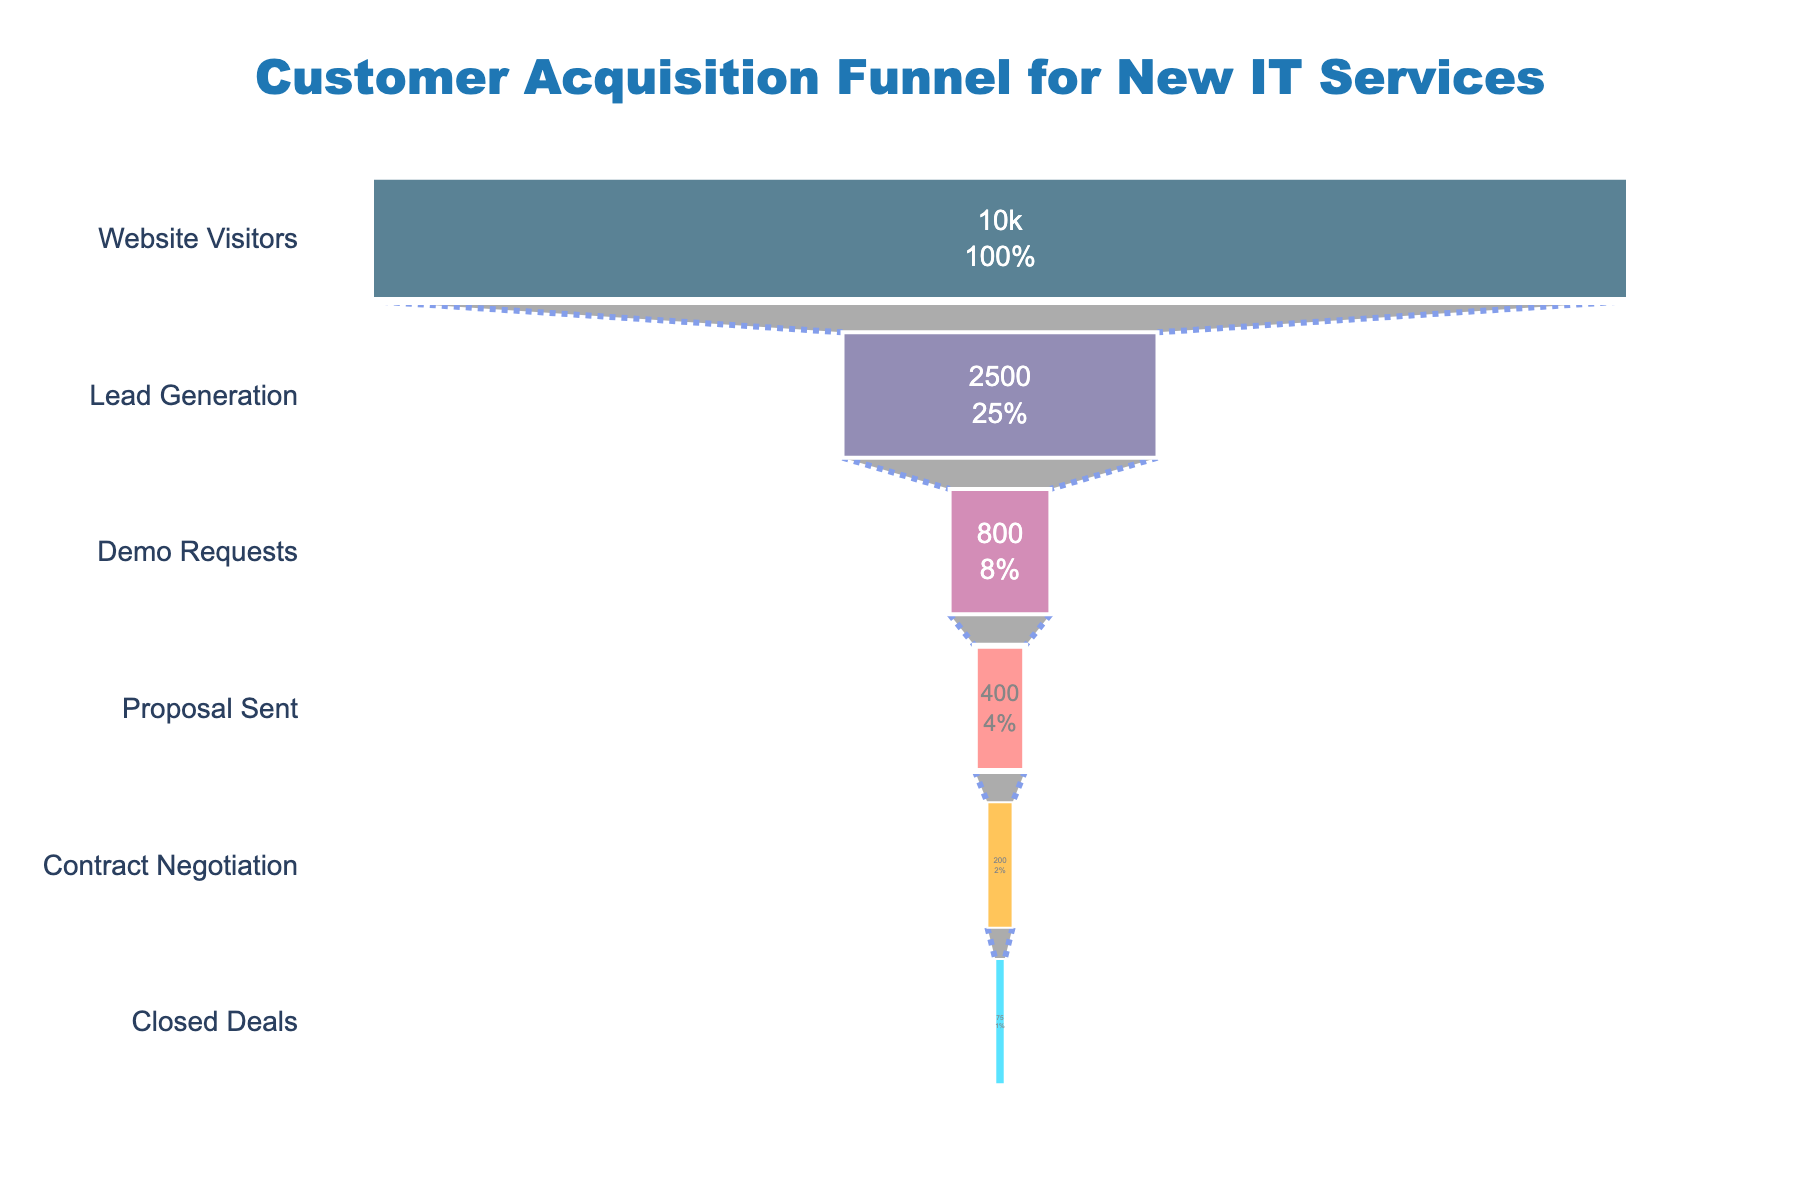How many total stages are shown in the funnel chart? The funnel chart displays multiple stages, starting from 'Website Visitors' and proceeding to 'Closed Deals'. By counting these stages, we find there are six distinct stages.
Answer: 6 Which stage has the highest number of prospects? By looking at the funnel chart, we see that 'Website Visitors' is the stage with the most prospects, at 10,000.
Answer: Website Visitors What percentage of prospects reach the 'Demo Requests' stage? To find the percentage, divide the number of 'Demo Requests' (800) by the number of 'Website Visitors' (10,000) and multiply by 100. Calculation: (800 / 10,000) * 100 = 8%.
Answer: 8% How many prospects do not make it from 'Lead Generation' to 'Demo Requests'? Subtract the number of prospects at the 'Demo Requests' stage (800) from those at the 'Lead Generation' stage (2500). Calculation: 2500 - 800 = 1700.
Answer: 1700 Which stage has the highest drop-off rate from the previous stage? To find the highest drop-off rate, calculate the drop-off percentage between each consecutive stage: 
- From 'Website Visitors' to 'Lead Generation': (10000 - 2500) / 10000 * 100 = 75%
- From 'Lead Generation' to 'Demo Requests': (2500 - 800) / 2500 * 100 = 68%
- From 'Demo Requests' to 'Proposal Sent': (800 - 400) / 800 * 100 = 50%
- From 'Proposal Sent' to 'Contract Negotiation': (400 - 200) / 400 * 100 = 50%
- From 'Contract Negotiation' to 'Closed Deals': (200 - 75) / 200 * 100 = 62.5%
The highest drop-off rate is from 'Website Visitors' to 'Lead Generation' at 75%.
Answer: Website Visitors to Lead Generation What is the total percentage drop from 'Website Visitors' to 'Closed Deals'? Calculate the total drop percentage by subtracting the percentage that reach 'Closed Deals' from 100%. Only 75 prospects reached 'Closed Deals' out of 10,000 'Website Visitors'. Calculation: (75 / 10,000) * 100 = 0.75%, then 100% - 0.75% = 99.25%.
Answer: 99.25% Between which stages does the number of prospects halve for the first time? Inspect the funnel chart to find the first instance where the number of prospects falls to half or fewer:  
- From 'Website Visitors' (10,000) to 'Lead Generation' (2,500): Drop exceeds half. 
- Between 'Lead Generation' (2,500) and 'Demo Requests' (800): Remaining prospects less than half. 
By examining these values, we see the prospects halve first between 'Website Visitors' and 'Lead Generation'.
Answer: Website Visitors and Lead Generation 